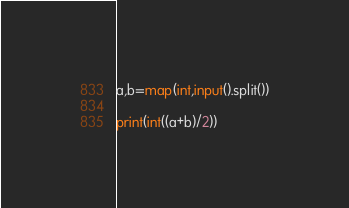<code> <loc_0><loc_0><loc_500><loc_500><_Python_>a,b=map(int,input().split())

print(int((a+b)/2))
</code> 